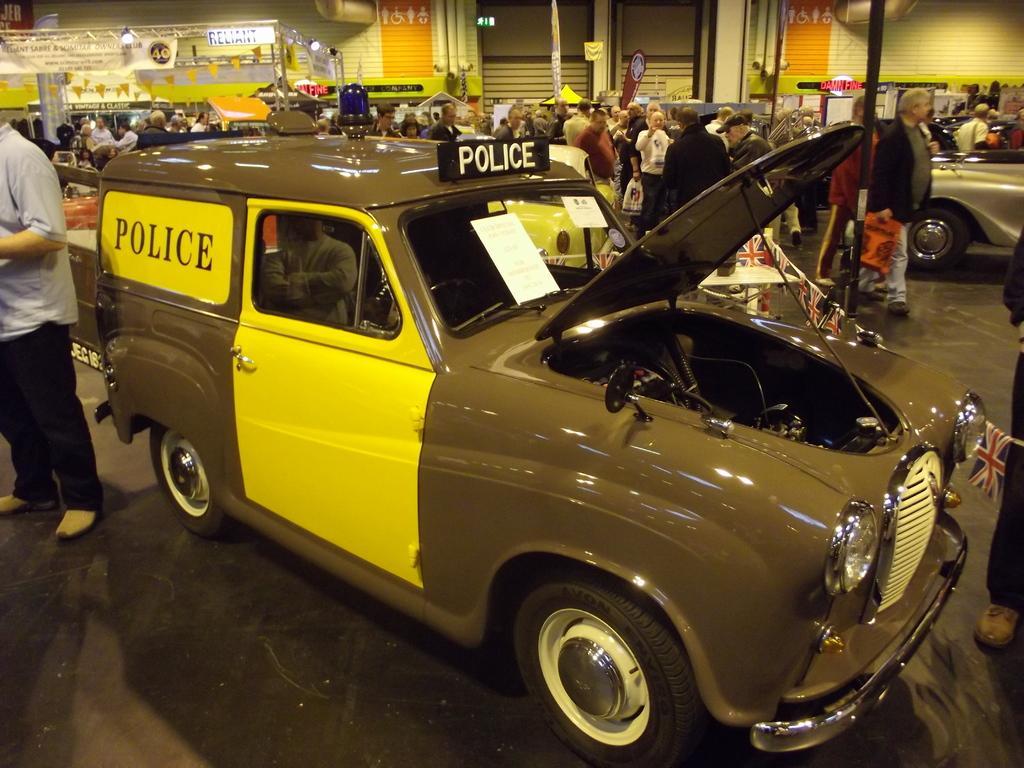Can you describe this image briefly? In this image we can see a group of people are standing on the road, there is the car, there is the windshield, there are the tires, there is the pole, where are the lights. 